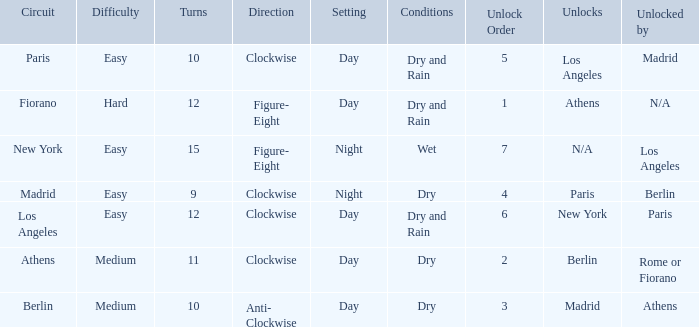How many instances is paris the unlock? 1.0. 